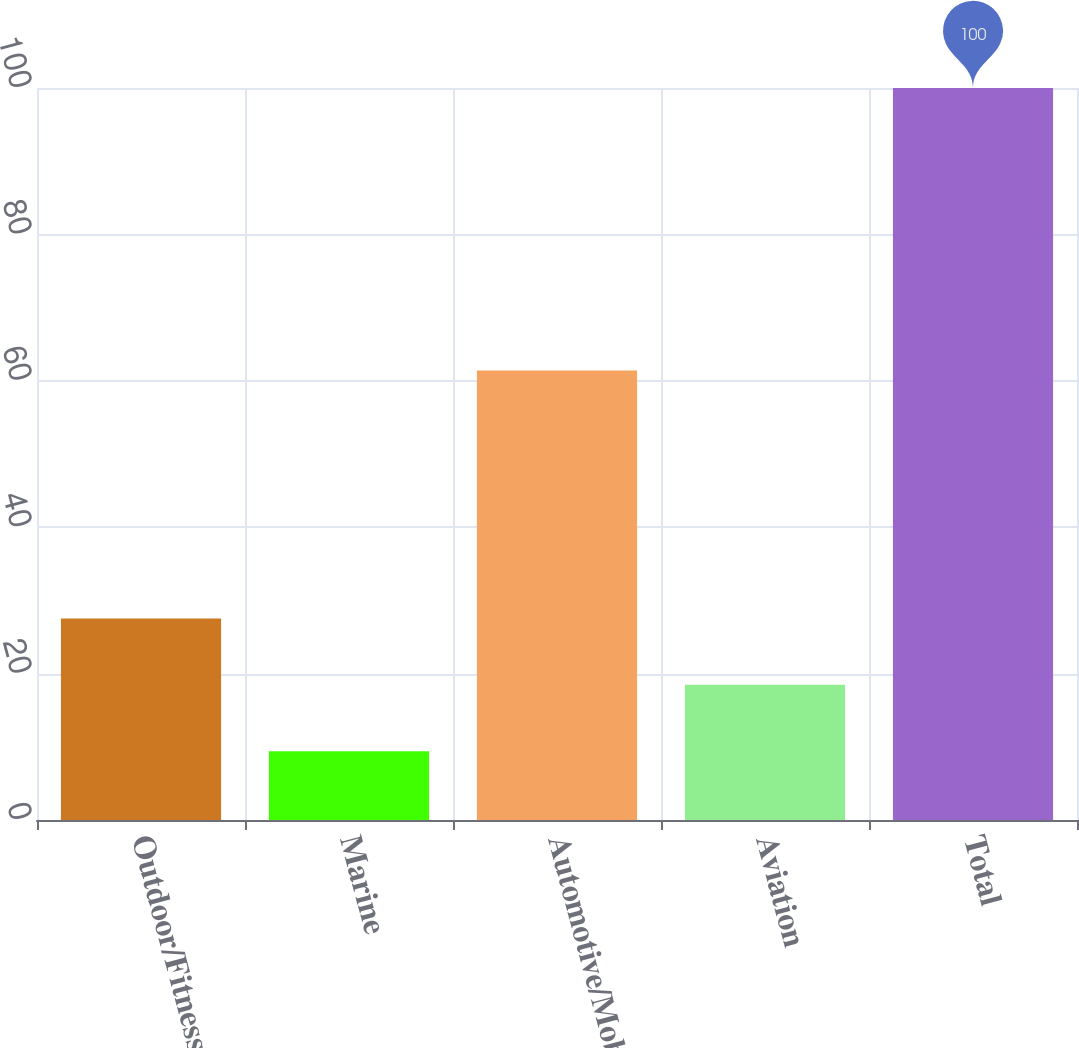Convert chart to OTSL. <chart><loc_0><loc_0><loc_500><loc_500><bar_chart><fcel>Outdoor/Fitness<fcel>Marine<fcel>Automotive/Mobile<fcel>Aviation<fcel>Total<nl><fcel>27.52<fcel>9.4<fcel>61.4<fcel>18.46<fcel>100<nl></chart> 